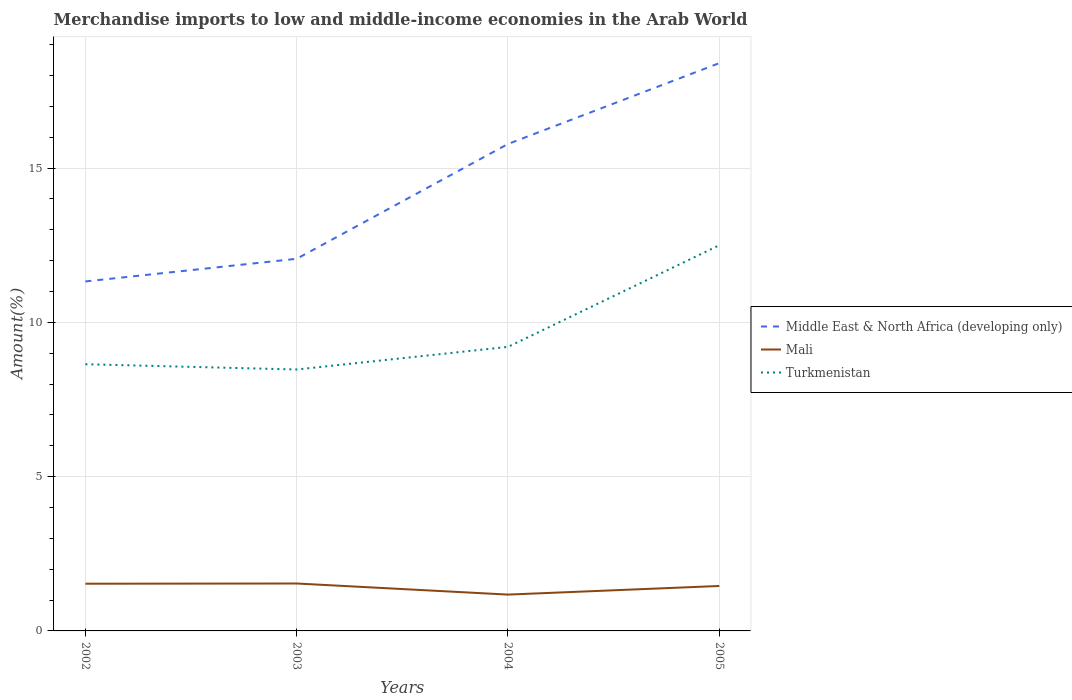How many different coloured lines are there?
Provide a short and direct response. 3. Does the line corresponding to Middle East & North Africa (developing only) intersect with the line corresponding to Mali?
Offer a very short reply. No. Across all years, what is the maximum percentage of amount earned from merchandise imports in Mali?
Make the answer very short. 1.18. What is the total percentage of amount earned from merchandise imports in Turkmenistan in the graph?
Your answer should be very brief. -0.73. What is the difference between the highest and the second highest percentage of amount earned from merchandise imports in Middle East & North Africa (developing only)?
Provide a short and direct response. 7.07. What is the difference between the highest and the lowest percentage of amount earned from merchandise imports in Turkmenistan?
Your answer should be compact. 1. How many years are there in the graph?
Offer a terse response. 4. What is the difference between two consecutive major ticks on the Y-axis?
Your response must be concise. 5. Are the values on the major ticks of Y-axis written in scientific E-notation?
Provide a short and direct response. No. Where does the legend appear in the graph?
Ensure brevity in your answer.  Center right. What is the title of the graph?
Your answer should be compact. Merchandise imports to low and middle-income economies in the Arab World. Does "Panama" appear as one of the legend labels in the graph?
Your answer should be very brief. No. What is the label or title of the Y-axis?
Offer a terse response. Amount(%). What is the Amount(%) of Middle East & North Africa (developing only) in 2002?
Your answer should be very brief. 11.33. What is the Amount(%) of Mali in 2002?
Your answer should be compact. 1.53. What is the Amount(%) of Turkmenistan in 2002?
Provide a short and direct response. 8.64. What is the Amount(%) of Middle East & North Africa (developing only) in 2003?
Offer a terse response. 12.06. What is the Amount(%) of Mali in 2003?
Your answer should be very brief. 1.54. What is the Amount(%) of Turkmenistan in 2003?
Ensure brevity in your answer.  8.47. What is the Amount(%) in Middle East & North Africa (developing only) in 2004?
Provide a short and direct response. 15.78. What is the Amount(%) in Mali in 2004?
Give a very brief answer. 1.18. What is the Amount(%) of Turkmenistan in 2004?
Your answer should be compact. 9.21. What is the Amount(%) of Middle East & North Africa (developing only) in 2005?
Your response must be concise. 18.4. What is the Amount(%) in Mali in 2005?
Make the answer very short. 1.46. What is the Amount(%) of Turkmenistan in 2005?
Provide a short and direct response. 12.5. Across all years, what is the maximum Amount(%) in Middle East & North Africa (developing only)?
Your response must be concise. 18.4. Across all years, what is the maximum Amount(%) in Mali?
Ensure brevity in your answer.  1.54. Across all years, what is the maximum Amount(%) in Turkmenistan?
Give a very brief answer. 12.5. Across all years, what is the minimum Amount(%) of Middle East & North Africa (developing only)?
Provide a succinct answer. 11.33. Across all years, what is the minimum Amount(%) of Mali?
Make the answer very short. 1.18. Across all years, what is the minimum Amount(%) of Turkmenistan?
Ensure brevity in your answer.  8.47. What is the total Amount(%) in Middle East & North Africa (developing only) in the graph?
Your answer should be compact. 57.57. What is the total Amount(%) of Mali in the graph?
Your response must be concise. 5.7. What is the total Amount(%) in Turkmenistan in the graph?
Your answer should be compact. 38.82. What is the difference between the Amount(%) of Middle East & North Africa (developing only) in 2002 and that in 2003?
Keep it short and to the point. -0.73. What is the difference between the Amount(%) of Mali in 2002 and that in 2003?
Offer a very short reply. -0.01. What is the difference between the Amount(%) in Turkmenistan in 2002 and that in 2003?
Your answer should be compact. 0.17. What is the difference between the Amount(%) of Middle East & North Africa (developing only) in 2002 and that in 2004?
Provide a short and direct response. -4.45. What is the difference between the Amount(%) in Mali in 2002 and that in 2004?
Make the answer very short. 0.35. What is the difference between the Amount(%) of Turkmenistan in 2002 and that in 2004?
Offer a terse response. -0.56. What is the difference between the Amount(%) of Middle East & North Africa (developing only) in 2002 and that in 2005?
Provide a short and direct response. -7.07. What is the difference between the Amount(%) in Mali in 2002 and that in 2005?
Ensure brevity in your answer.  0.07. What is the difference between the Amount(%) in Turkmenistan in 2002 and that in 2005?
Ensure brevity in your answer.  -3.86. What is the difference between the Amount(%) in Middle East & North Africa (developing only) in 2003 and that in 2004?
Provide a short and direct response. -3.72. What is the difference between the Amount(%) in Mali in 2003 and that in 2004?
Keep it short and to the point. 0.36. What is the difference between the Amount(%) in Turkmenistan in 2003 and that in 2004?
Make the answer very short. -0.73. What is the difference between the Amount(%) of Middle East & North Africa (developing only) in 2003 and that in 2005?
Provide a succinct answer. -6.34. What is the difference between the Amount(%) of Mali in 2003 and that in 2005?
Give a very brief answer. 0.08. What is the difference between the Amount(%) of Turkmenistan in 2003 and that in 2005?
Offer a terse response. -4.03. What is the difference between the Amount(%) in Middle East & North Africa (developing only) in 2004 and that in 2005?
Offer a very short reply. -2.62. What is the difference between the Amount(%) of Mali in 2004 and that in 2005?
Make the answer very short. -0.28. What is the difference between the Amount(%) in Turkmenistan in 2004 and that in 2005?
Keep it short and to the point. -3.29. What is the difference between the Amount(%) of Middle East & North Africa (developing only) in 2002 and the Amount(%) of Mali in 2003?
Your answer should be compact. 9.79. What is the difference between the Amount(%) in Middle East & North Africa (developing only) in 2002 and the Amount(%) in Turkmenistan in 2003?
Keep it short and to the point. 2.85. What is the difference between the Amount(%) of Mali in 2002 and the Amount(%) of Turkmenistan in 2003?
Ensure brevity in your answer.  -6.94. What is the difference between the Amount(%) of Middle East & North Africa (developing only) in 2002 and the Amount(%) of Mali in 2004?
Provide a short and direct response. 10.15. What is the difference between the Amount(%) of Middle East & North Africa (developing only) in 2002 and the Amount(%) of Turkmenistan in 2004?
Your answer should be very brief. 2.12. What is the difference between the Amount(%) of Mali in 2002 and the Amount(%) of Turkmenistan in 2004?
Your response must be concise. -7.68. What is the difference between the Amount(%) in Middle East & North Africa (developing only) in 2002 and the Amount(%) in Mali in 2005?
Your answer should be compact. 9.87. What is the difference between the Amount(%) of Middle East & North Africa (developing only) in 2002 and the Amount(%) of Turkmenistan in 2005?
Keep it short and to the point. -1.17. What is the difference between the Amount(%) of Mali in 2002 and the Amount(%) of Turkmenistan in 2005?
Ensure brevity in your answer.  -10.97. What is the difference between the Amount(%) of Middle East & North Africa (developing only) in 2003 and the Amount(%) of Mali in 2004?
Provide a short and direct response. 10.88. What is the difference between the Amount(%) of Middle East & North Africa (developing only) in 2003 and the Amount(%) of Turkmenistan in 2004?
Offer a terse response. 2.85. What is the difference between the Amount(%) of Mali in 2003 and the Amount(%) of Turkmenistan in 2004?
Your answer should be very brief. -7.67. What is the difference between the Amount(%) in Middle East & North Africa (developing only) in 2003 and the Amount(%) in Mali in 2005?
Offer a very short reply. 10.6. What is the difference between the Amount(%) of Middle East & North Africa (developing only) in 2003 and the Amount(%) of Turkmenistan in 2005?
Your answer should be very brief. -0.44. What is the difference between the Amount(%) in Mali in 2003 and the Amount(%) in Turkmenistan in 2005?
Offer a terse response. -10.96. What is the difference between the Amount(%) in Middle East & North Africa (developing only) in 2004 and the Amount(%) in Mali in 2005?
Provide a short and direct response. 14.32. What is the difference between the Amount(%) in Middle East & North Africa (developing only) in 2004 and the Amount(%) in Turkmenistan in 2005?
Your response must be concise. 3.28. What is the difference between the Amount(%) in Mali in 2004 and the Amount(%) in Turkmenistan in 2005?
Provide a succinct answer. -11.32. What is the average Amount(%) in Middle East & North Africa (developing only) per year?
Make the answer very short. 14.39. What is the average Amount(%) of Mali per year?
Give a very brief answer. 1.43. What is the average Amount(%) of Turkmenistan per year?
Make the answer very short. 9.7. In the year 2002, what is the difference between the Amount(%) in Middle East & North Africa (developing only) and Amount(%) in Mali?
Offer a terse response. 9.8. In the year 2002, what is the difference between the Amount(%) of Middle East & North Africa (developing only) and Amount(%) of Turkmenistan?
Offer a terse response. 2.68. In the year 2002, what is the difference between the Amount(%) of Mali and Amount(%) of Turkmenistan?
Your answer should be very brief. -7.11. In the year 2003, what is the difference between the Amount(%) in Middle East & North Africa (developing only) and Amount(%) in Mali?
Your response must be concise. 10.52. In the year 2003, what is the difference between the Amount(%) in Middle East & North Africa (developing only) and Amount(%) in Turkmenistan?
Your answer should be compact. 3.59. In the year 2003, what is the difference between the Amount(%) of Mali and Amount(%) of Turkmenistan?
Provide a short and direct response. -6.94. In the year 2004, what is the difference between the Amount(%) in Middle East & North Africa (developing only) and Amount(%) in Mali?
Provide a short and direct response. 14.6. In the year 2004, what is the difference between the Amount(%) of Middle East & North Africa (developing only) and Amount(%) of Turkmenistan?
Give a very brief answer. 6.57. In the year 2004, what is the difference between the Amount(%) of Mali and Amount(%) of Turkmenistan?
Your answer should be very brief. -8.03. In the year 2005, what is the difference between the Amount(%) of Middle East & North Africa (developing only) and Amount(%) of Mali?
Keep it short and to the point. 16.94. In the year 2005, what is the difference between the Amount(%) of Middle East & North Africa (developing only) and Amount(%) of Turkmenistan?
Make the answer very short. 5.9. In the year 2005, what is the difference between the Amount(%) in Mali and Amount(%) in Turkmenistan?
Your answer should be compact. -11.04. What is the ratio of the Amount(%) of Middle East & North Africa (developing only) in 2002 to that in 2003?
Offer a terse response. 0.94. What is the ratio of the Amount(%) in Turkmenistan in 2002 to that in 2003?
Your answer should be very brief. 1.02. What is the ratio of the Amount(%) in Middle East & North Africa (developing only) in 2002 to that in 2004?
Provide a succinct answer. 0.72. What is the ratio of the Amount(%) of Mali in 2002 to that in 2004?
Provide a short and direct response. 1.3. What is the ratio of the Amount(%) in Turkmenistan in 2002 to that in 2004?
Offer a terse response. 0.94. What is the ratio of the Amount(%) of Middle East & North Africa (developing only) in 2002 to that in 2005?
Your answer should be compact. 0.62. What is the ratio of the Amount(%) in Mali in 2002 to that in 2005?
Provide a short and direct response. 1.05. What is the ratio of the Amount(%) in Turkmenistan in 2002 to that in 2005?
Your answer should be very brief. 0.69. What is the ratio of the Amount(%) in Middle East & North Africa (developing only) in 2003 to that in 2004?
Ensure brevity in your answer.  0.76. What is the ratio of the Amount(%) of Mali in 2003 to that in 2004?
Offer a very short reply. 1.3. What is the ratio of the Amount(%) of Turkmenistan in 2003 to that in 2004?
Your answer should be very brief. 0.92. What is the ratio of the Amount(%) of Middle East & North Africa (developing only) in 2003 to that in 2005?
Provide a short and direct response. 0.66. What is the ratio of the Amount(%) of Mali in 2003 to that in 2005?
Give a very brief answer. 1.05. What is the ratio of the Amount(%) in Turkmenistan in 2003 to that in 2005?
Offer a terse response. 0.68. What is the ratio of the Amount(%) of Middle East & North Africa (developing only) in 2004 to that in 2005?
Ensure brevity in your answer.  0.86. What is the ratio of the Amount(%) of Mali in 2004 to that in 2005?
Offer a terse response. 0.81. What is the ratio of the Amount(%) of Turkmenistan in 2004 to that in 2005?
Your answer should be very brief. 0.74. What is the difference between the highest and the second highest Amount(%) of Middle East & North Africa (developing only)?
Offer a very short reply. 2.62. What is the difference between the highest and the second highest Amount(%) of Mali?
Provide a succinct answer. 0.01. What is the difference between the highest and the second highest Amount(%) of Turkmenistan?
Ensure brevity in your answer.  3.29. What is the difference between the highest and the lowest Amount(%) of Middle East & North Africa (developing only)?
Offer a very short reply. 7.07. What is the difference between the highest and the lowest Amount(%) of Mali?
Your response must be concise. 0.36. What is the difference between the highest and the lowest Amount(%) of Turkmenistan?
Your answer should be compact. 4.03. 